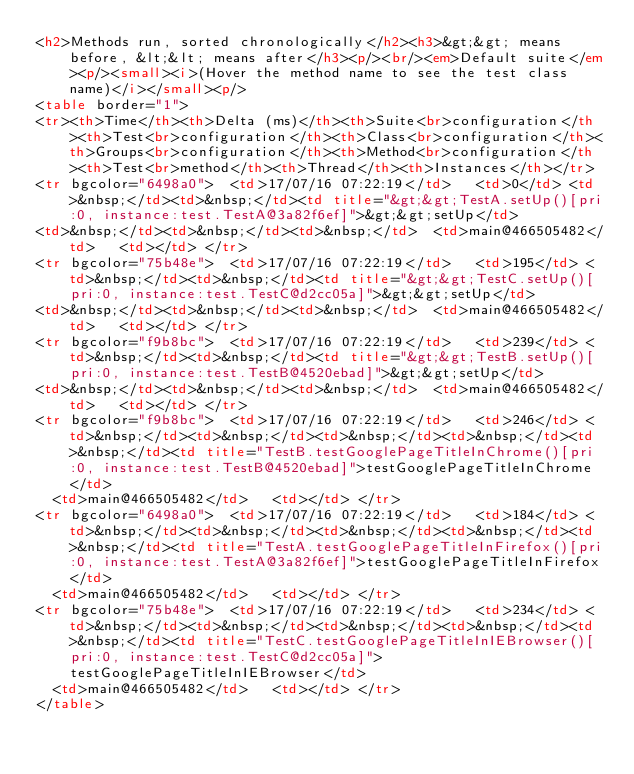Convert code to text. <code><loc_0><loc_0><loc_500><loc_500><_HTML_><h2>Methods run, sorted chronologically</h2><h3>&gt;&gt; means before, &lt;&lt; means after</h3><p/><br/><em>Default suite</em><p/><small><i>(Hover the method name to see the test class name)</i></small><p/>
<table border="1">
<tr><th>Time</th><th>Delta (ms)</th><th>Suite<br>configuration</th><th>Test<br>configuration</th><th>Class<br>configuration</th><th>Groups<br>configuration</th><th>Method<br>configuration</th><th>Test<br>method</th><th>Thread</th><th>Instances</th></tr>
<tr bgcolor="6498a0">  <td>17/07/16 07:22:19</td>   <td>0</td> <td>&nbsp;</td><td>&nbsp;</td><td title="&gt;&gt;TestA.setUp()[pri:0, instance:test.TestA@3a82f6ef]">&gt;&gt;setUp</td> 
<td>&nbsp;</td><td>&nbsp;</td><td>&nbsp;</td>  <td>main@466505482</td>   <td></td> </tr>
<tr bgcolor="75b48e">  <td>17/07/16 07:22:19</td>   <td>195</td> <td>&nbsp;</td><td>&nbsp;</td><td title="&gt;&gt;TestC.setUp()[pri:0, instance:test.TestC@d2cc05a]">&gt;&gt;setUp</td> 
<td>&nbsp;</td><td>&nbsp;</td><td>&nbsp;</td>  <td>main@466505482</td>   <td></td> </tr>
<tr bgcolor="f9b8bc">  <td>17/07/16 07:22:19</td>   <td>239</td> <td>&nbsp;</td><td>&nbsp;</td><td title="&gt;&gt;TestB.setUp()[pri:0, instance:test.TestB@4520ebad]">&gt;&gt;setUp</td> 
<td>&nbsp;</td><td>&nbsp;</td><td>&nbsp;</td>  <td>main@466505482</td>   <td></td> </tr>
<tr bgcolor="f9b8bc">  <td>17/07/16 07:22:19</td>   <td>246</td> <td>&nbsp;</td><td>&nbsp;</td><td>&nbsp;</td><td>&nbsp;</td><td>&nbsp;</td><td title="TestB.testGooglePageTitleInChrome()[pri:0, instance:test.TestB@4520ebad]">testGooglePageTitleInChrome</td> 
  <td>main@466505482</td>   <td></td> </tr>
<tr bgcolor="6498a0">  <td>17/07/16 07:22:19</td>   <td>184</td> <td>&nbsp;</td><td>&nbsp;</td><td>&nbsp;</td><td>&nbsp;</td><td>&nbsp;</td><td title="TestA.testGooglePageTitleInFirefox()[pri:0, instance:test.TestA@3a82f6ef]">testGooglePageTitleInFirefox</td> 
  <td>main@466505482</td>   <td></td> </tr>
<tr bgcolor="75b48e">  <td>17/07/16 07:22:19</td>   <td>234</td> <td>&nbsp;</td><td>&nbsp;</td><td>&nbsp;</td><td>&nbsp;</td><td>&nbsp;</td><td title="TestC.testGooglePageTitleInIEBrowser()[pri:0, instance:test.TestC@d2cc05a]">testGooglePageTitleInIEBrowser</td> 
  <td>main@466505482</td>   <td></td> </tr>
</table>
</code> 